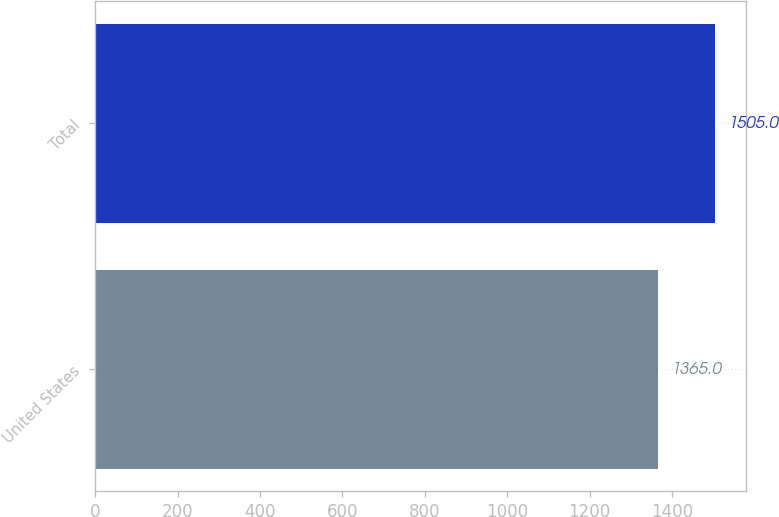Convert chart to OTSL. <chart><loc_0><loc_0><loc_500><loc_500><bar_chart><fcel>United States<fcel>Total<nl><fcel>1365<fcel>1505<nl></chart> 